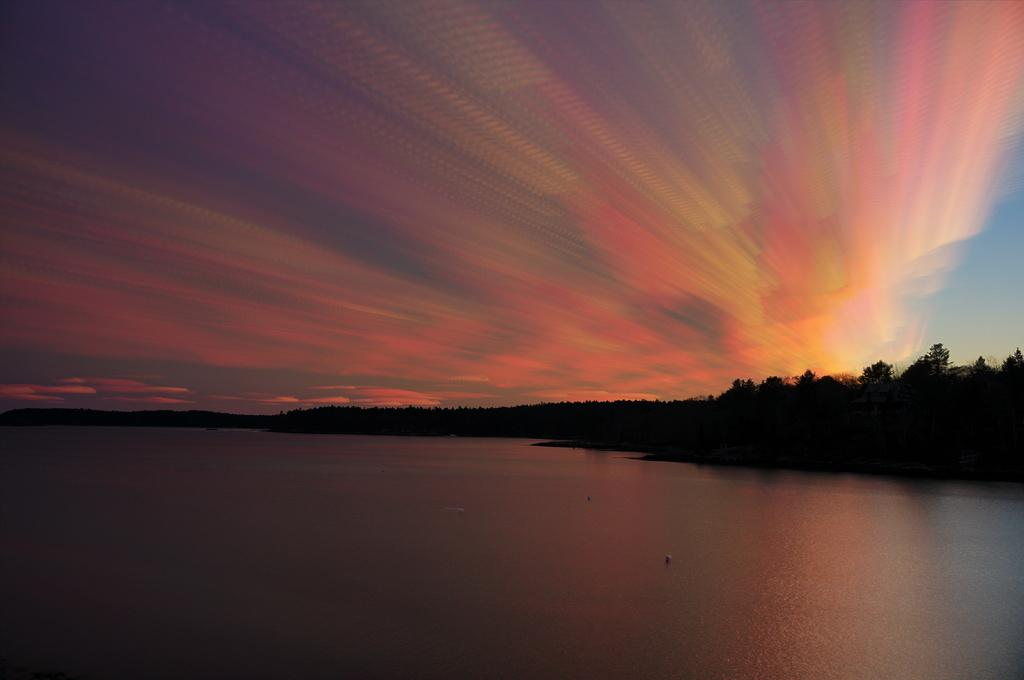What type of natural feature can be seen in the image? There is a river in the image. What other natural elements are present in the image? There are trees in the image. How would you describe the sky in the background? The sky in the background has yellow, orange, orange, and red colors. What type of lunch is being served in the image? There is no lunch present in the image; it features a river, trees, and a colored sky. 